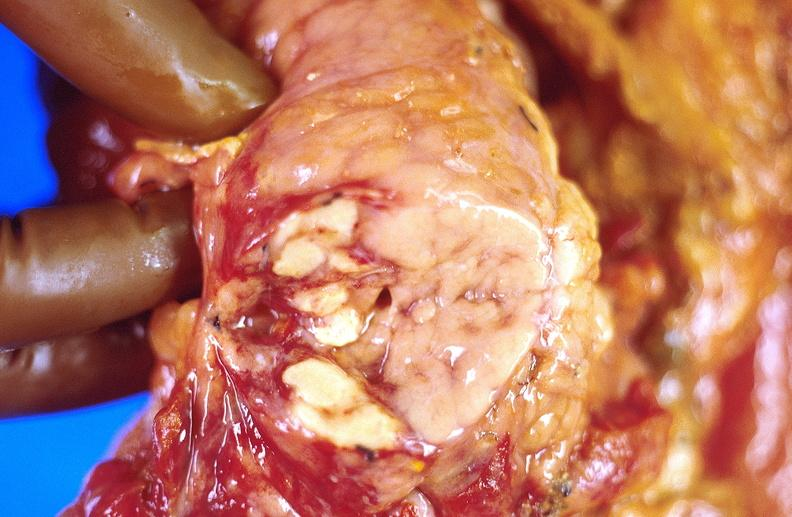does this image show pancreatic fat necrosis, transplanted pancreas?
Answer the question using a single word or phrase. Yes 